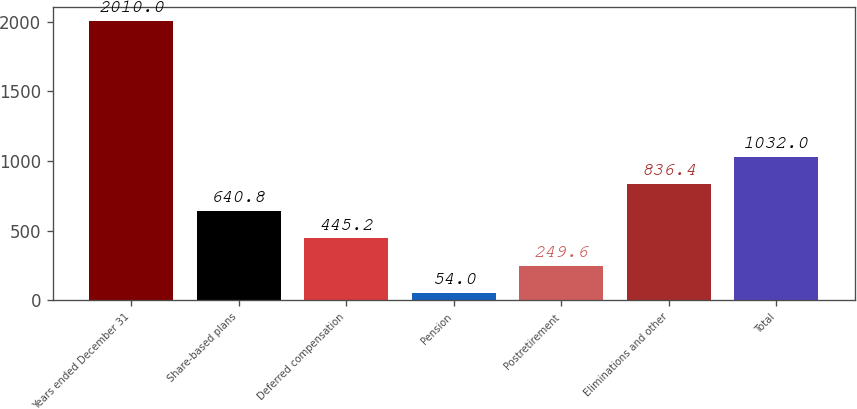Convert chart. <chart><loc_0><loc_0><loc_500><loc_500><bar_chart><fcel>Years ended December 31<fcel>Share-based plans<fcel>Deferred compensation<fcel>Pension<fcel>Postretirement<fcel>Eliminations and other<fcel>Total<nl><fcel>2010<fcel>640.8<fcel>445.2<fcel>54<fcel>249.6<fcel>836.4<fcel>1032<nl></chart> 